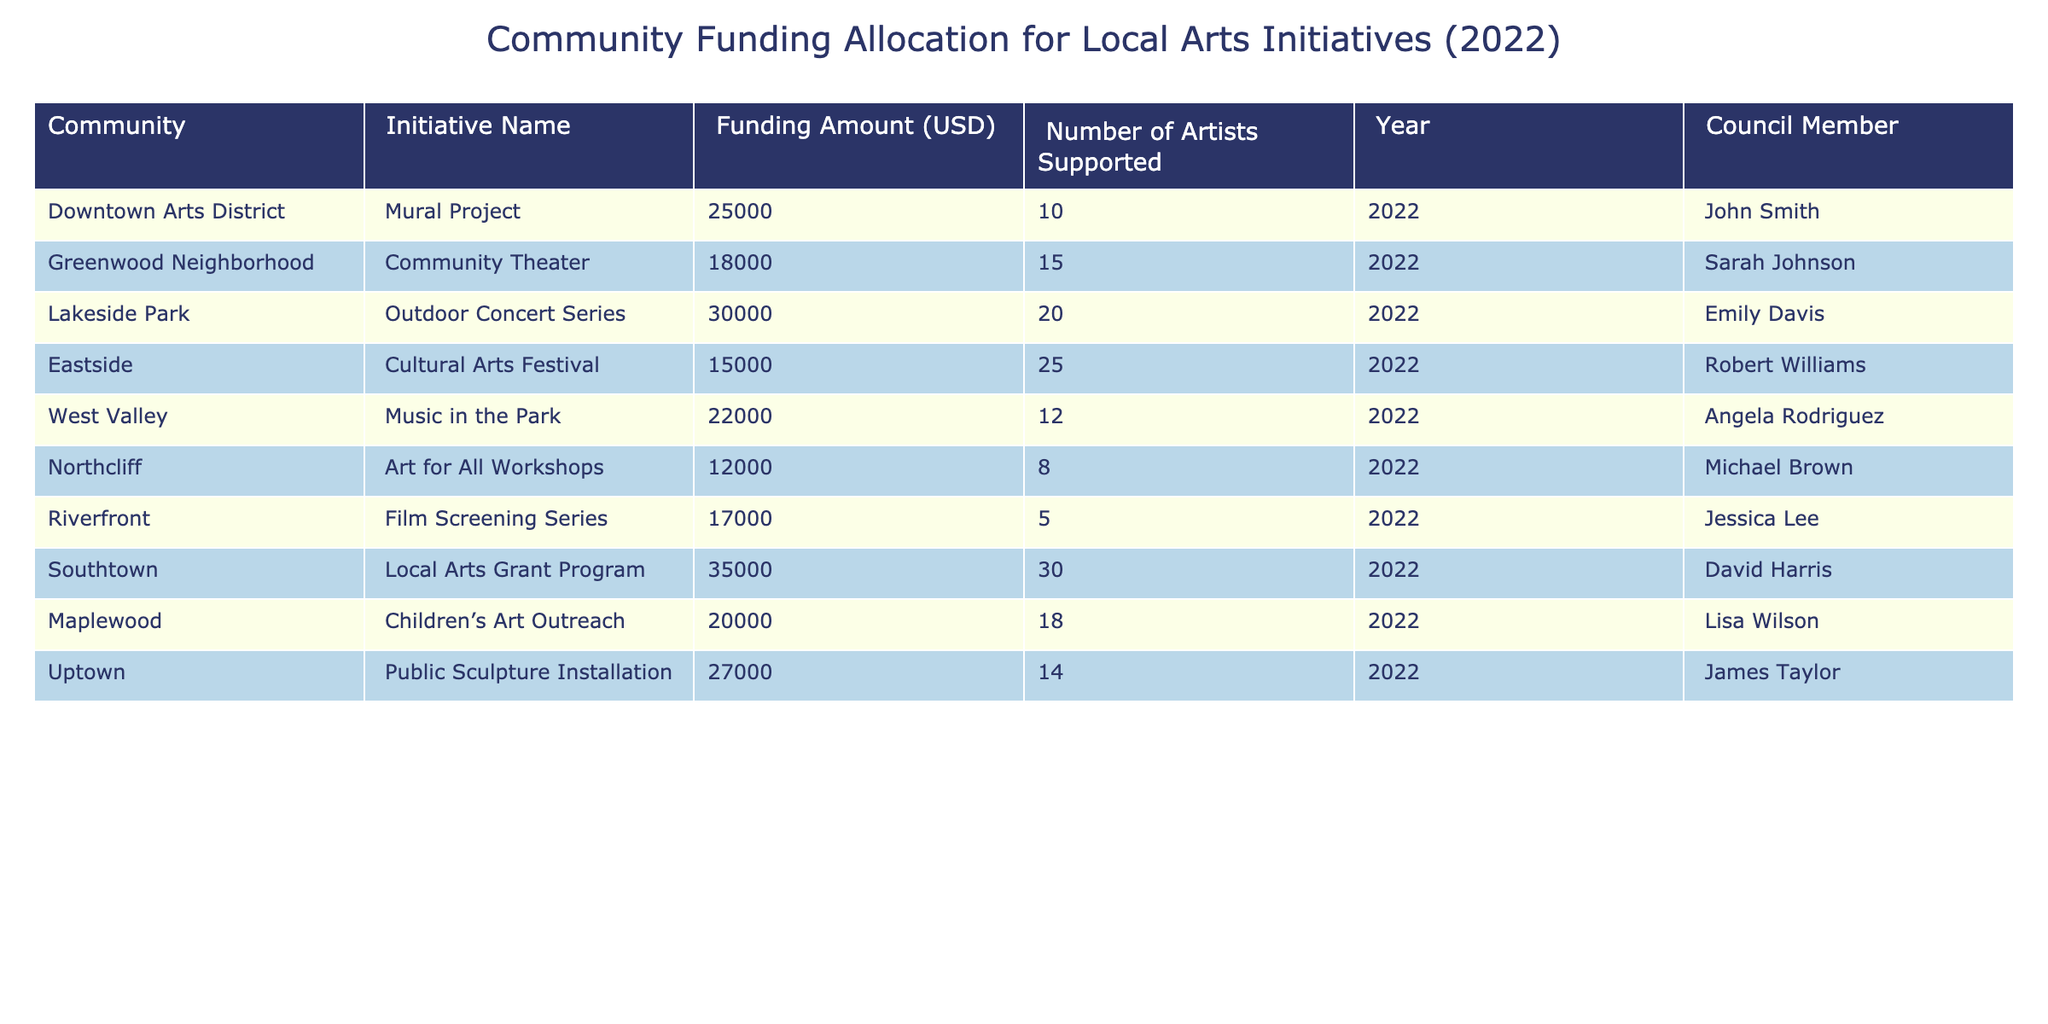What is the total funding amount allocated for all initiatives in 2022? To find the total funding, we need to sum the individual funding amounts from each initiative: 25000 + 18000 + 30000 + 15000 + 22000 + 12000 + 17000 + 35000 + 20000 + 27000 = 226000.
Answer: 226000 Which initiative has the highest funding amount? By comparing the funding amounts in the table, Lakeside Park's Outdoor Concert Series has the highest funding at 30000.
Answer: Outdoor Concert Series How many artists were supported by the Eastside initiative? The table shows that the Eastside Cultural Arts Festival supported 25 artists.
Answer: 25 What is the average number of artists supported across all initiatives? To find the average, sum the number of artists supported (10 + 15 + 20 + 25 + 12 + 8 + 5 + 30 + 18 + 14 =  165), then divide by the number of initiatives (10): 165 / 10 = 16.5.
Answer: 16.5 Did the Southtown initiative receive more funding than the Greenwood Neighborhood initiative? Southtown received 35000 while Greenwood Neighborhood received 18000. Since 35000 > 18000, the statement is true.
Answer: Yes What initiative had the least number of artists supported? By examining the number of artists in the table, the Film Screening Series under Riverfront shows the least support with only 5 artists.
Answer: Film Screening Series What percentage of the funding went to the Lakeside Park initiative compared to the total funding? The funding for Lakeside Park is 30000. To calculate the percentage: (30000 / 226000) * 100 ≈ 13.27%.
Answer: 13.27% Which council member supported the largest community arts initiative? The Lakeside Park initiative, which had the largest funding, was supported by Emily Davis.
Answer: Emily Davis How many initiatives received funding of 20000 or more? Reviewing the funding amounts, the initiatives that received 20000 or more are: Mural Project, Outdoor Concert Series, Music in the Park, Local Arts Grant Program, Children’s Art Outreach, and Public Sculpture Installation, totaling 6 initiatives.
Answer: 6 Is there any initiative that supported more than 30 artists? The table shows that the maximum number of artists supported was 30 through the Local Arts Grant Program, so there are no initiatives that supported more than this number.
Answer: No 